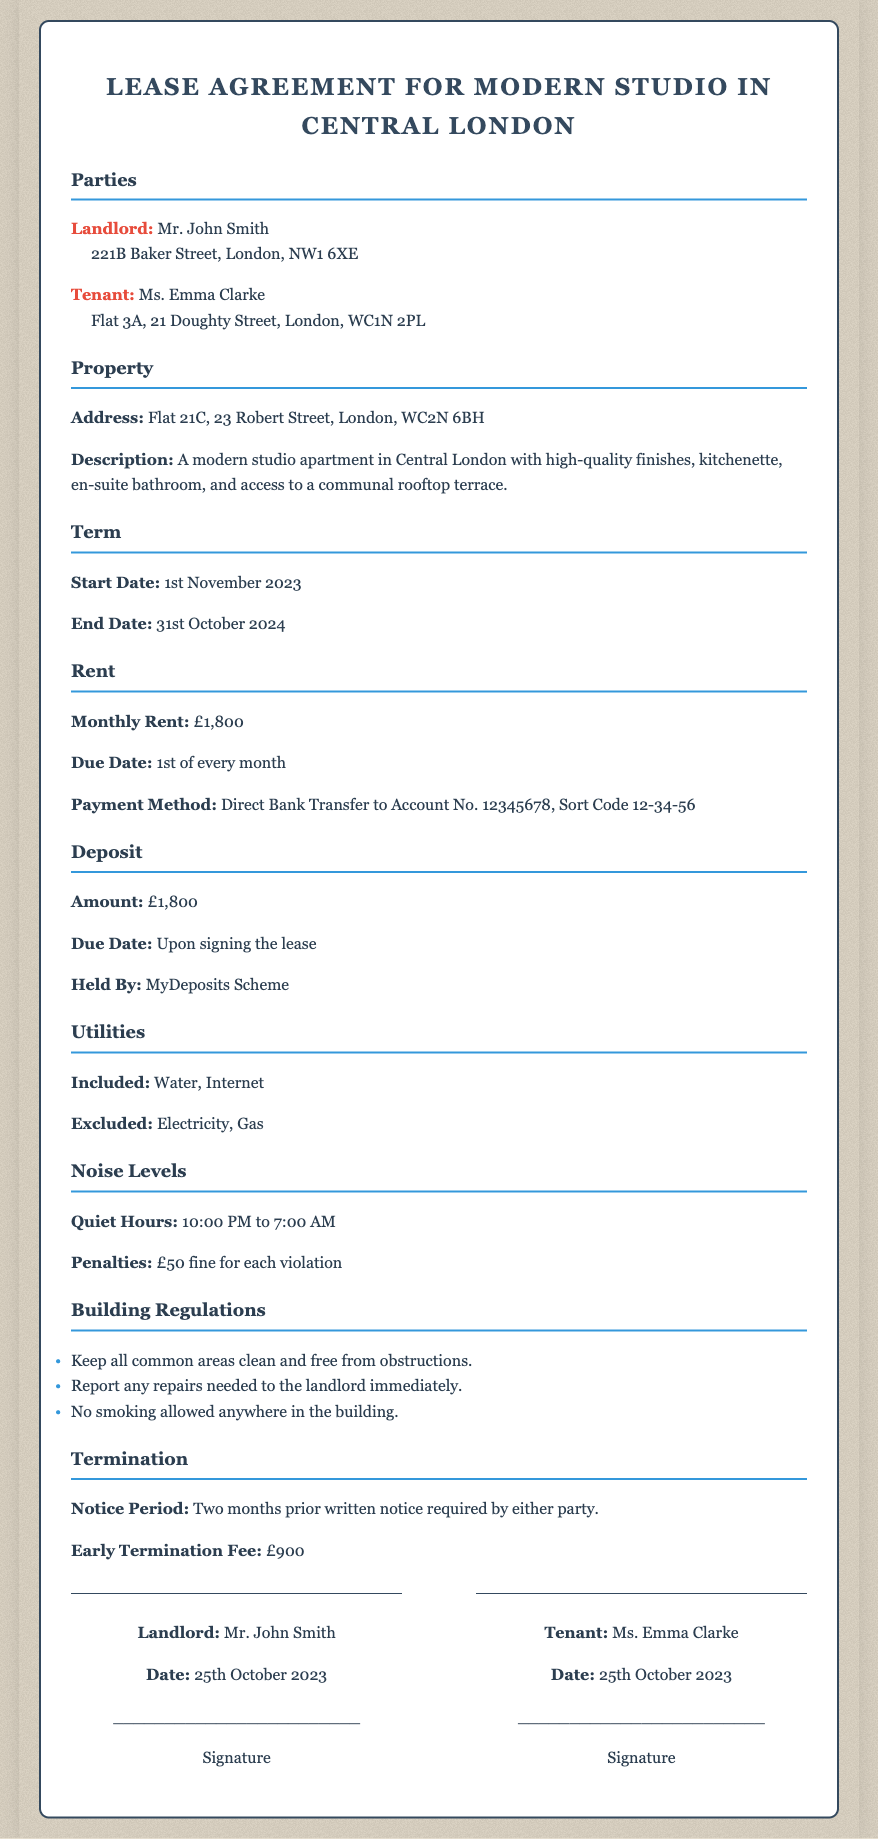what is the monthly rent? The monthly rent is specified in the Rent section of the document as £1,800.
Answer: £1,800 who is the landlord? The landlord's name is stated in the Parties section as Mr. John Smith.
Answer: Mr. John Smith what is the early termination fee? The early termination fee is mentioned in the Termination section of the document as £900.
Answer: £900 when does the lease start? The start date of the lease is detailed in the Term section and is 1st November 2023.
Answer: 1st November 2023 what are the quiet hours? The document specifies quiet hours under Noise Levels as 10:00 PM to 7:00 AM.
Answer: 10:00 PM to 7:00 AM how long is the notice period for termination? The notice period for termination is found in the Termination section and is two months notice.
Answer: Two months what utilities are included in the rent? Included utilities are listed in the Utilities section as Water and Internet.
Answer: Water, Internet what address is the property located at? The property address is stated in the Property section as Flat 21C, 23 Robert Street, London, WC2N 6BH.
Answer: Flat 21C, 23 Robert Street, London, WC2N 6BH what is the deposit amount? The deposit amount is indicated in the Deposit section and is £1,800.
Answer: £1,800 